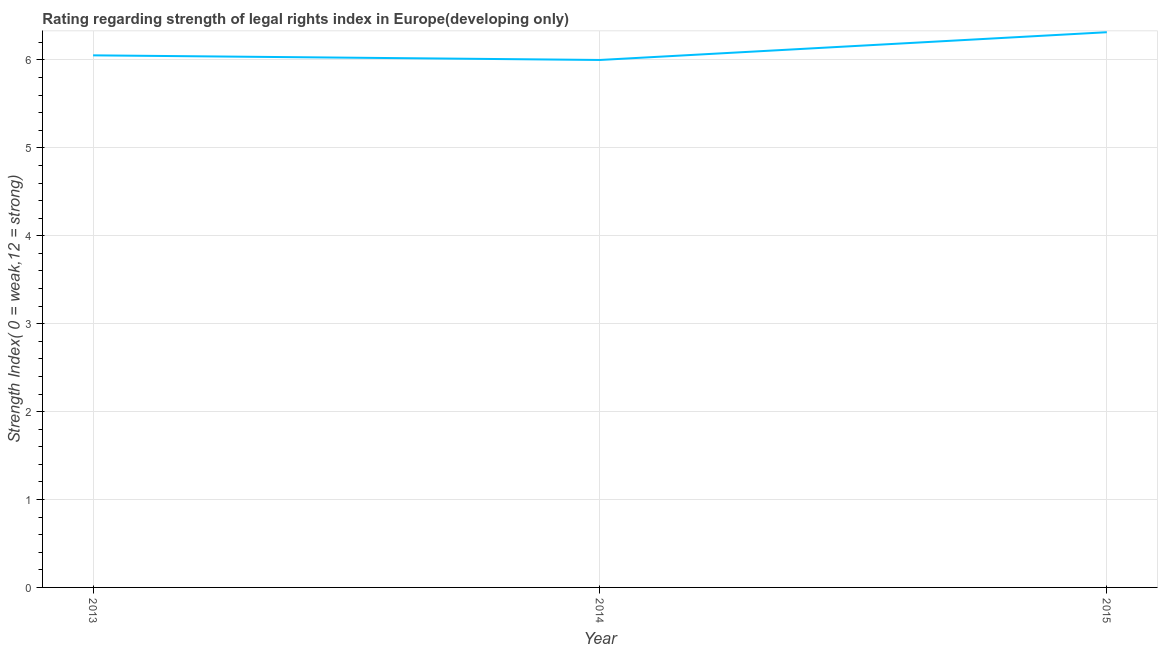What is the strength of legal rights index in 2015?
Offer a terse response. 6.32. Across all years, what is the maximum strength of legal rights index?
Make the answer very short. 6.32. Across all years, what is the minimum strength of legal rights index?
Provide a short and direct response. 6. In which year was the strength of legal rights index maximum?
Keep it short and to the point. 2015. What is the sum of the strength of legal rights index?
Offer a terse response. 18.37. What is the difference between the strength of legal rights index in 2014 and 2015?
Your response must be concise. -0.32. What is the average strength of legal rights index per year?
Offer a terse response. 6.12. What is the median strength of legal rights index?
Provide a short and direct response. 6.05. Do a majority of the years between 2013 and 2014 (inclusive) have strength of legal rights index greater than 2.4 ?
Keep it short and to the point. Yes. What is the ratio of the strength of legal rights index in 2013 to that in 2014?
Provide a short and direct response. 1.01. What is the difference between the highest and the second highest strength of legal rights index?
Give a very brief answer. 0.26. What is the difference between the highest and the lowest strength of legal rights index?
Your answer should be compact. 0.32. In how many years, is the strength of legal rights index greater than the average strength of legal rights index taken over all years?
Provide a short and direct response. 1. How many years are there in the graph?
Your answer should be very brief. 3. What is the difference between two consecutive major ticks on the Y-axis?
Give a very brief answer. 1. Are the values on the major ticks of Y-axis written in scientific E-notation?
Keep it short and to the point. No. What is the title of the graph?
Your response must be concise. Rating regarding strength of legal rights index in Europe(developing only). What is the label or title of the X-axis?
Ensure brevity in your answer.  Year. What is the label or title of the Y-axis?
Provide a succinct answer. Strength Index( 0 = weak,12 = strong). What is the Strength Index( 0 = weak,12 = strong) in 2013?
Your answer should be very brief. 6.05. What is the Strength Index( 0 = weak,12 = strong) in 2014?
Make the answer very short. 6. What is the Strength Index( 0 = weak,12 = strong) of 2015?
Offer a very short reply. 6.32. What is the difference between the Strength Index( 0 = weak,12 = strong) in 2013 and 2014?
Offer a terse response. 0.05. What is the difference between the Strength Index( 0 = weak,12 = strong) in 2013 and 2015?
Offer a terse response. -0.26. What is the difference between the Strength Index( 0 = weak,12 = strong) in 2014 and 2015?
Ensure brevity in your answer.  -0.32. What is the ratio of the Strength Index( 0 = weak,12 = strong) in 2013 to that in 2014?
Your answer should be very brief. 1.01. What is the ratio of the Strength Index( 0 = weak,12 = strong) in 2013 to that in 2015?
Your response must be concise. 0.96. What is the ratio of the Strength Index( 0 = weak,12 = strong) in 2014 to that in 2015?
Your answer should be compact. 0.95. 